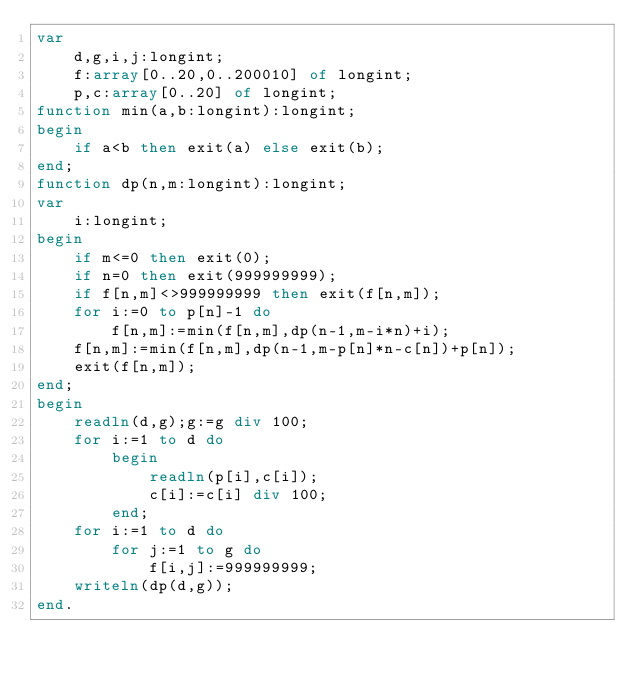<code> <loc_0><loc_0><loc_500><loc_500><_Pascal_>var
    d,g,i,j:longint;
    f:array[0..20,0..200010] of longint;
    p,c:array[0..20] of longint;
function min(a,b:longint):longint;
begin
    if a<b then exit(a) else exit(b);
end;
function dp(n,m:longint):longint;
var
    i:longint;
begin
    if m<=0 then exit(0);
    if n=0 then exit(999999999);
    if f[n,m]<>999999999 then exit(f[n,m]);
    for i:=0 to p[n]-1 do
        f[n,m]:=min(f[n,m],dp(n-1,m-i*n)+i);
    f[n,m]:=min(f[n,m],dp(n-1,m-p[n]*n-c[n])+p[n]);
    exit(f[n,m]);
end;
begin
    readln(d,g);g:=g div 100;
    for i:=1 to d do
        begin
            readln(p[i],c[i]);
            c[i]:=c[i] div 100;
        end;
    for i:=1 to d do
        for j:=1 to g do
            f[i,j]:=999999999;
    writeln(dp(d,g));
end.</code> 